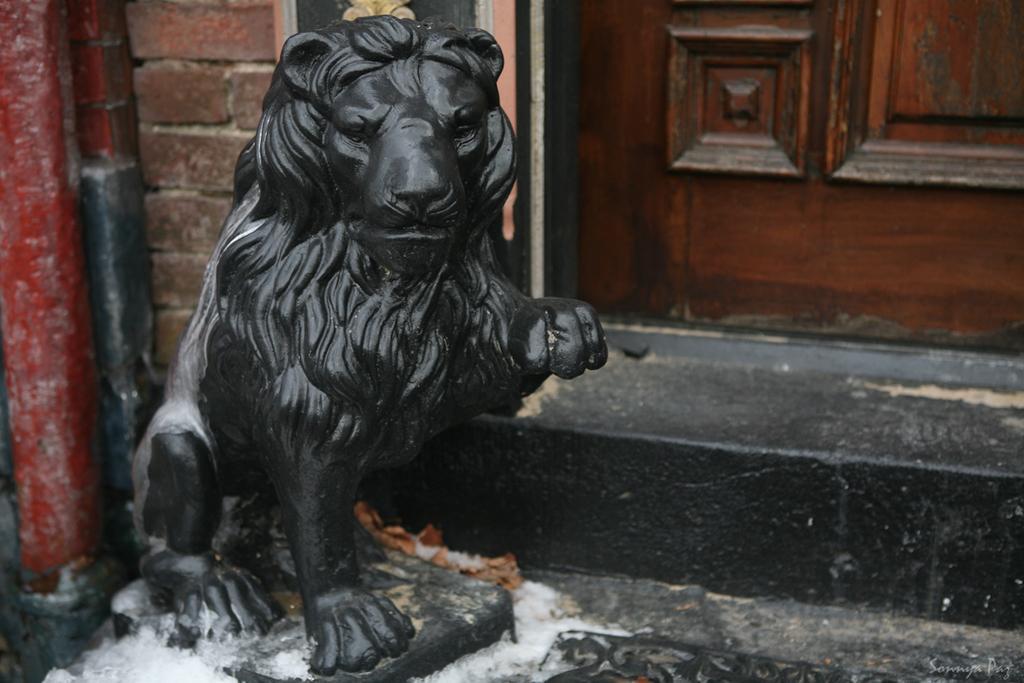How would you summarize this image in a sentence or two? In this image we can see there is a depiction of a lion. In the background there is a wooden door. 